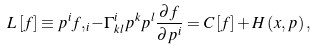Convert formula to latex. <formula><loc_0><loc_0><loc_500><loc_500>L \left [ f \right ] \equiv p ^ { i } f , _ { i } - \Gamma ^ { i } _ { k l } p ^ { k } p ^ { l } \frac { \partial f } { \partial p ^ { i } } = C \left [ f \right ] + H \left ( x , p \right ) ,</formula> 